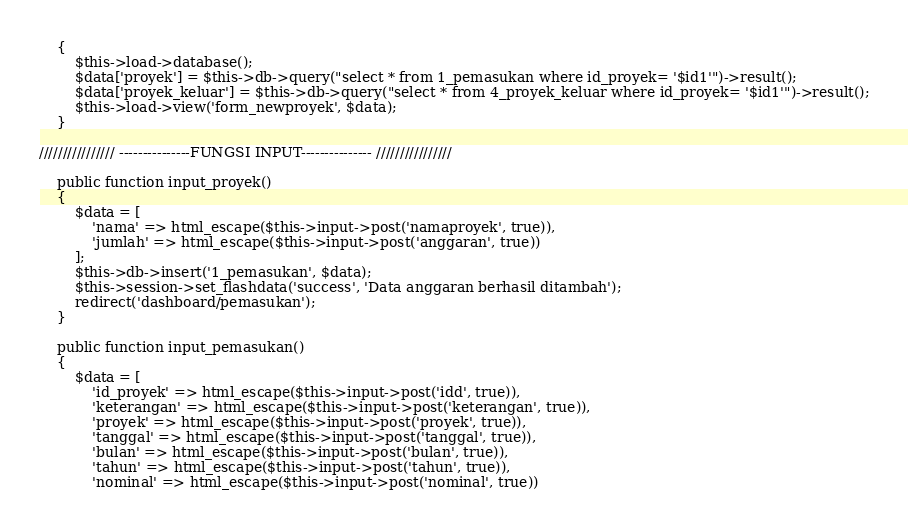Convert code to text. <code><loc_0><loc_0><loc_500><loc_500><_PHP_>	{
		$this->load->database();
		$data['proyek'] = $this->db->query("select * from 1_pemasukan where id_proyek= '$id1'")->result();
		$data['proyek_keluar'] = $this->db->query("select * from 4_proyek_keluar where id_proyek= '$id1'")->result();
		$this->load->view('form_newproyek', $data);
	}

//////////////// ---------------FUNGSI INPUT--------------- ////////////////

	public function input_proyek()
	{
		$data = [
			'nama' => html_escape($this->input->post('namaproyek', true)),
			'jumlah' => html_escape($this->input->post('anggaran', true))
		];
		$this->db->insert('1_pemasukan', $data);
		$this->session->set_flashdata('success', 'Data anggaran berhasil ditambah');
		redirect('dashboard/pemasukan');
	}

	public function input_pemasukan()
	{
		$data = [
			'id_proyek' => html_escape($this->input->post('idd', true)),
			'keterangan' => html_escape($this->input->post('keterangan', true)),
			'proyek' => html_escape($this->input->post('proyek', true)),
			'tanggal' => html_escape($this->input->post('tanggal', true)),
			'bulan' => html_escape($this->input->post('bulan', true)),
			'tahun' => html_escape($this->input->post('tahun', true)),
			'nominal' => html_escape($this->input->post('nominal', true))</code> 